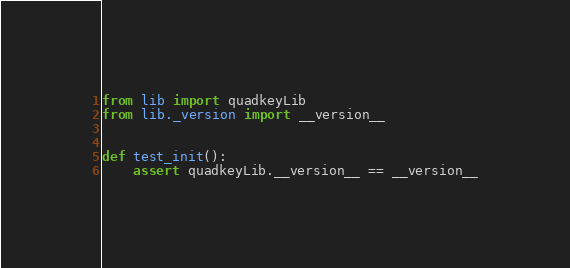<code> <loc_0><loc_0><loc_500><loc_500><_Python_>from lib import quadkeyLib
from lib._version import __version__


def test_init():
    assert quadkeyLib.__version__ == __version__</code> 